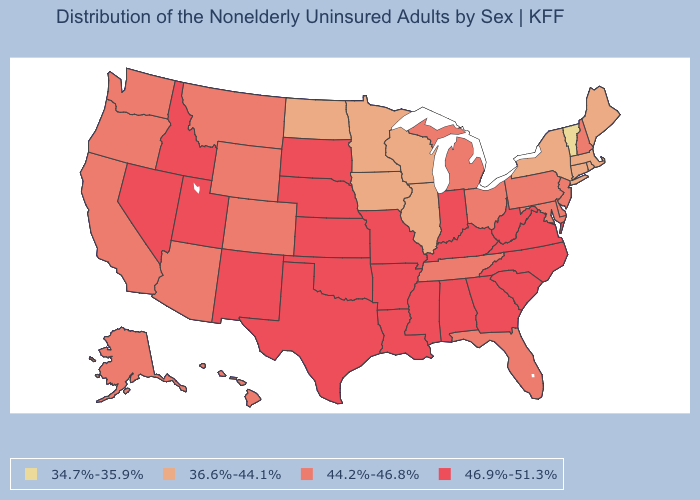Does Michigan have a higher value than West Virginia?
Be succinct. No. Does the map have missing data?
Concise answer only. No. What is the value of Alabama?
Answer briefly. 46.9%-51.3%. Among the states that border Nevada , which have the lowest value?
Concise answer only. Arizona, California, Oregon. Name the states that have a value in the range 34.7%-35.9%?
Short answer required. Vermont. Name the states that have a value in the range 44.2%-46.8%?
Give a very brief answer. Alaska, Arizona, California, Colorado, Delaware, Florida, Hawaii, Maryland, Michigan, Montana, New Hampshire, New Jersey, Ohio, Oregon, Pennsylvania, Tennessee, Washington, Wyoming. Among the states that border Kansas , does Colorado have the lowest value?
Give a very brief answer. Yes. Name the states that have a value in the range 44.2%-46.8%?
Be succinct. Alaska, Arizona, California, Colorado, Delaware, Florida, Hawaii, Maryland, Michigan, Montana, New Hampshire, New Jersey, Ohio, Oregon, Pennsylvania, Tennessee, Washington, Wyoming. What is the highest value in the MidWest ?
Concise answer only. 46.9%-51.3%. Is the legend a continuous bar?
Give a very brief answer. No. What is the lowest value in states that border Maine?
Give a very brief answer. 44.2%-46.8%. What is the lowest value in the West?
Keep it brief. 44.2%-46.8%. What is the value of Louisiana?
Concise answer only. 46.9%-51.3%. 